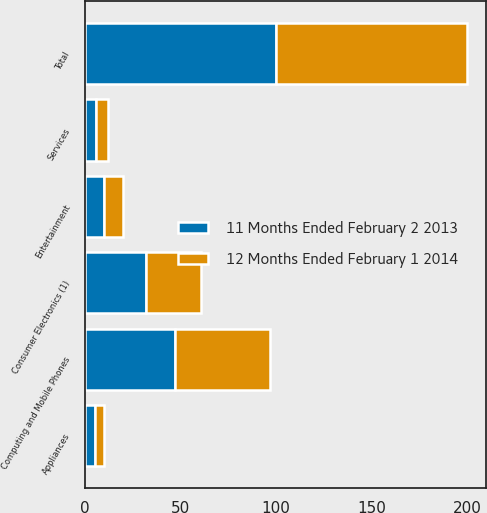<chart> <loc_0><loc_0><loc_500><loc_500><stacked_bar_chart><ecel><fcel>Consumer Electronics (1)<fcel>Computing and Mobile Phones<fcel>Entertainment<fcel>Appliances<fcel>Services<fcel>Total<nl><fcel>12 Months Ended February 1 2014<fcel>29<fcel>50<fcel>10<fcel>5<fcel>6<fcel>100<nl><fcel>11 Months Ended February 2 2013<fcel>32<fcel>47<fcel>10<fcel>5<fcel>6<fcel>100<nl></chart> 